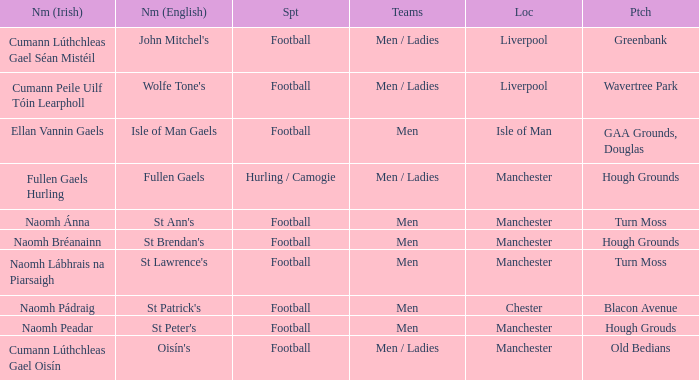What Pitch is located at Isle of Man? GAA Grounds, Douglas. 